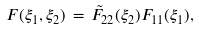<formula> <loc_0><loc_0><loc_500><loc_500>F ( \xi _ { 1 } , \xi _ { 2 } ) \, = \, \tilde { F } _ { 2 2 } ( \xi _ { 2 } ) F _ { 1 1 } ( \xi _ { 1 } ) ,</formula> 